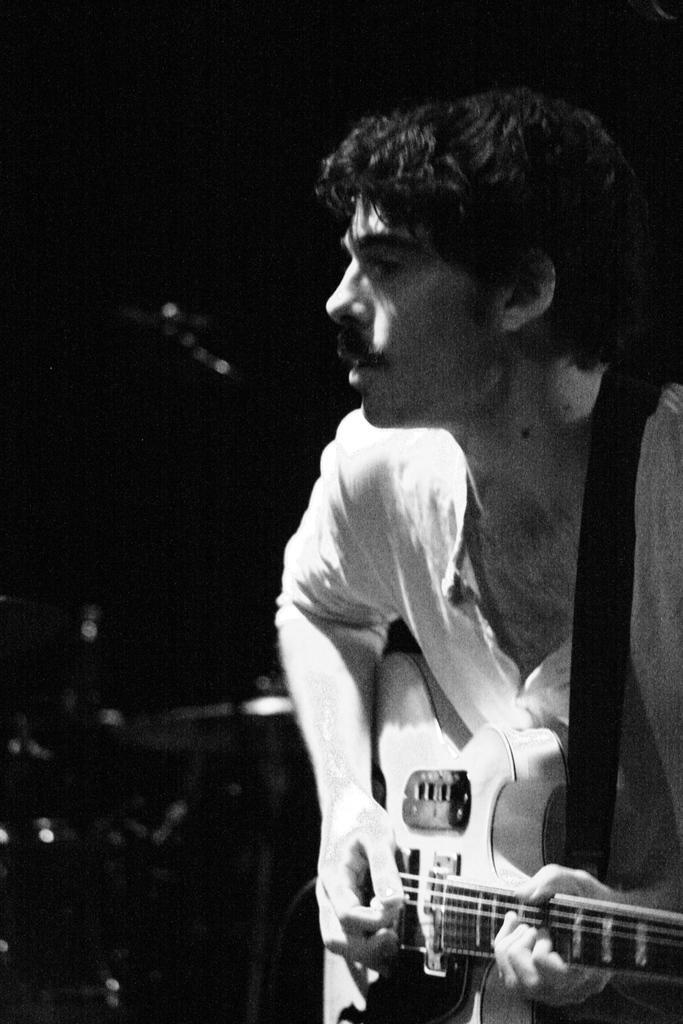In one or two sentences, can you explain what this image depicts? In this picture there is a man holding a guitar and playing it 